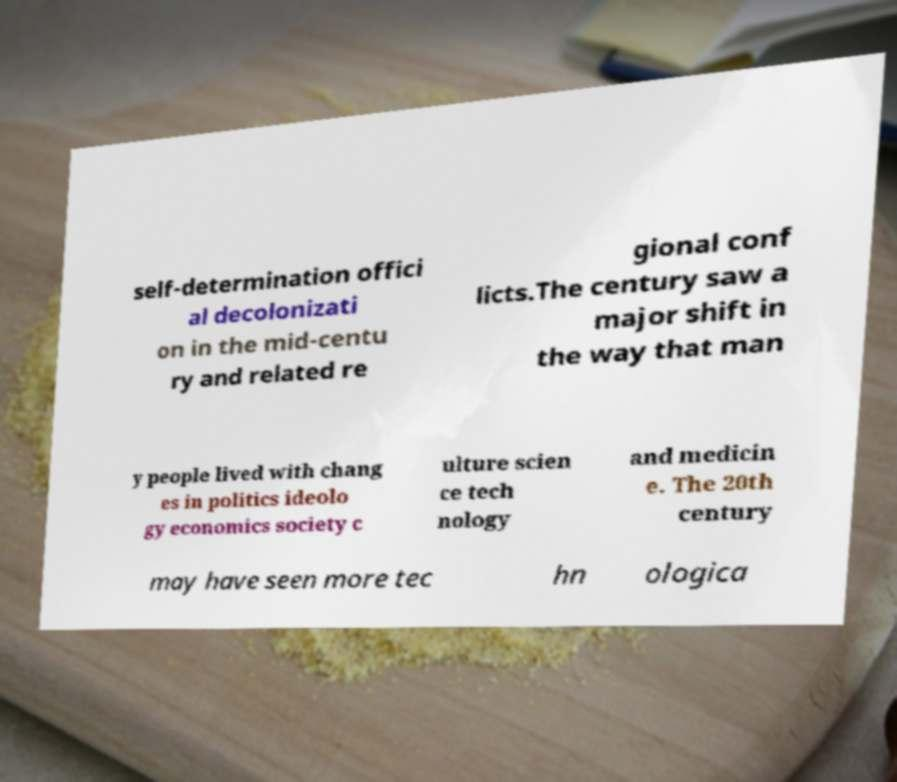For documentation purposes, I need the text within this image transcribed. Could you provide that? self-determination offici al decolonizati on in the mid-centu ry and related re gional conf licts.The century saw a major shift in the way that man y people lived with chang es in politics ideolo gy economics society c ulture scien ce tech nology and medicin e. The 20th century may have seen more tec hn ologica 